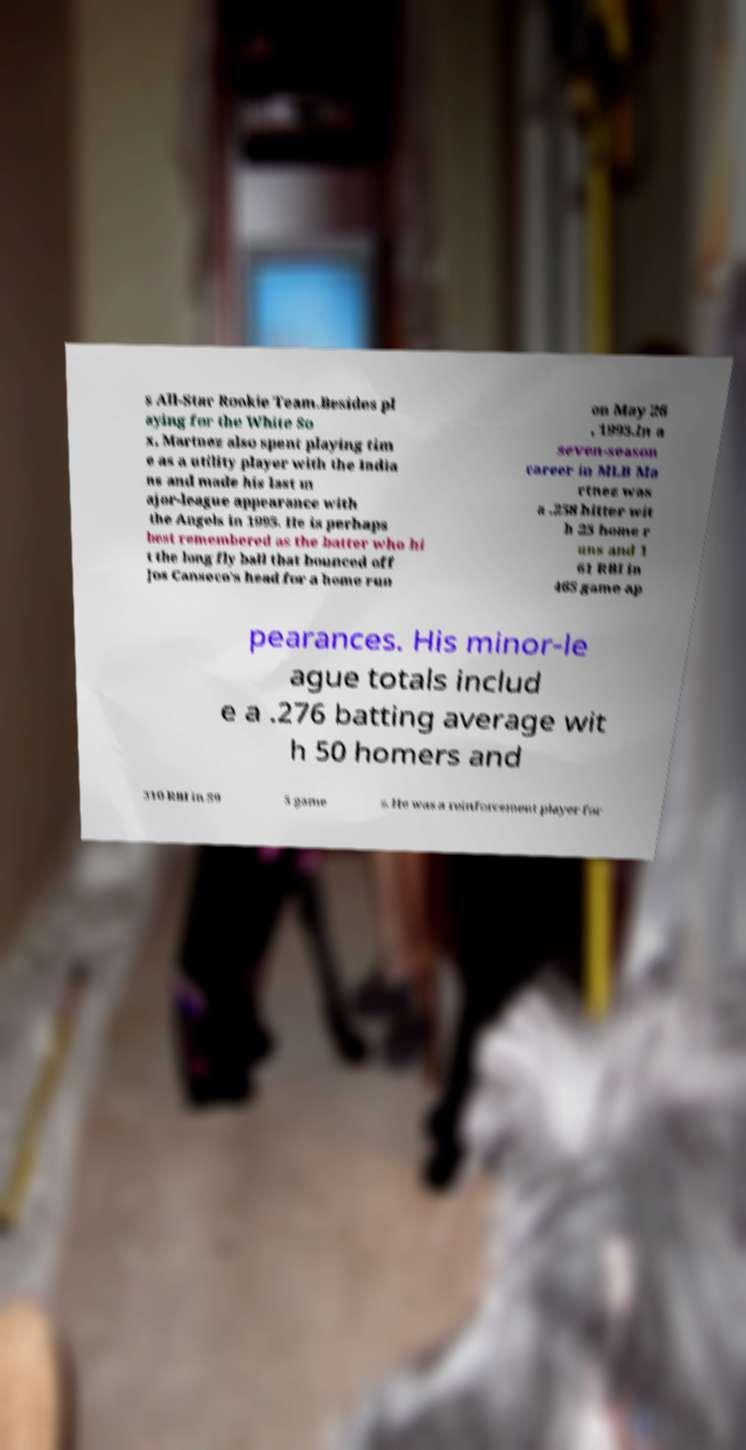Could you extract and type out the text from this image? s All-Star Rookie Team.Besides pl aying for the White So x, Martnez also spent playing tim e as a utility player with the India ns and made his last m ajor-league appearance with the Angels in 1995. He is perhaps best remembered as the batter who hi t the long fly ball that bounced off Jos Canseco's head for a home run on May 26 , 1993.In a seven-season career in MLB Ma rtnez was a .258 hitter wit h 25 home r uns and 1 61 RBI in 465 game ap pearances. His minor-le ague totals includ e a .276 batting average wit h 50 homers and 310 RBI in 59 5 game s. He was a reinforcement player for 